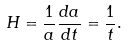Convert formula to latex. <formula><loc_0><loc_0><loc_500><loc_500>H = \frac { 1 } { a } \frac { d a } { d t } = \frac { 1 } { t } .</formula> 